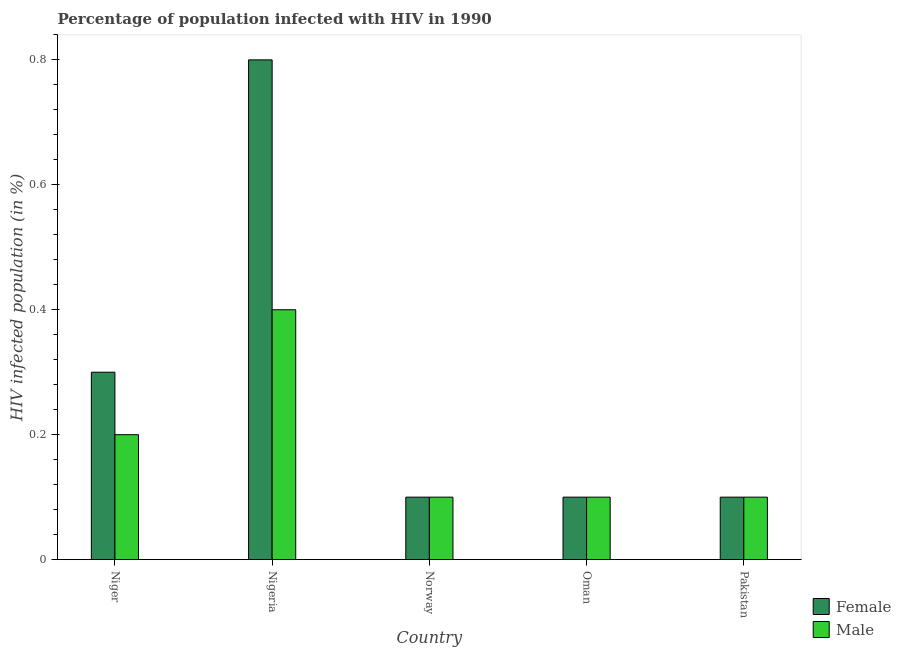What is the percentage of males who are infected with hiv in Oman?
Offer a terse response. 0.1. Across all countries, what is the maximum percentage of females who are infected with hiv?
Your answer should be compact. 0.8. In which country was the percentage of males who are infected with hiv maximum?
Offer a very short reply. Nigeria. What is the total percentage of females who are infected with hiv in the graph?
Ensure brevity in your answer.  1.4. What is the difference between the percentage of females who are infected with hiv in Nigeria and that in Norway?
Make the answer very short. 0.7. What is the average percentage of females who are infected with hiv per country?
Your answer should be very brief. 0.28. What is the ratio of the percentage of males who are infected with hiv in Niger to that in Nigeria?
Offer a very short reply. 0.5. What is the difference between the highest and the lowest percentage of females who are infected with hiv?
Make the answer very short. 0.7. Is the sum of the percentage of males who are infected with hiv in Norway and Oman greater than the maximum percentage of females who are infected with hiv across all countries?
Give a very brief answer. No. What does the 2nd bar from the left in Oman represents?
Offer a very short reply. Male. What does the 2nd bar from the right in Niger represents?
Ensure brevity in your answer.  Female. How many bars are there?
Make the answer very short. 10. Are all the bars in the graph horizontal?
Offer a terse response. No. Are the values on the major ticks of Y-axis written in scientific E-notation?
Your answer should be compact. No. Does the graph contain any zero values?
Your answer should be very brief. No. Does the graph contain grids?
Keep it short and to the point. No. How are the legend labels stacked?
Your answer should be very brief. Vertical. What is the title of the graph?
Your response must be concise. Percentage of population infected with HIV in 1990. Does "Research and Development" appear as one of the legend labels in the graph?
Offer a terse response. No. What is the label or title of the X-axis?
Your answer should be compact. Country. What is the label or title of the Y-axis?
Provide a short and direct response. HIV infected population (in %). What is the HIV infected population (in %) of Female in Norway?
Your answer should be compact. 0.1. What is the HIV infected population (in %) of Male in Oman?
Give a very brief answer. 0.1. What is the HIV infected population (in %) in Female in Pakistan?
Ensure brevity in your answer.  0.1. What is the HIV infected population (in %) in Male in Pakistan?
Provide a short and direct response. 0.1. Across all countries, what is the maximum HIV infected population (in %) in Male?
Provide a succinct answer. 0.4. Across all countries, what is the minimum HIV infected population (in %) in Female?
Give a very brief answer. 0.1. What is the difference between the HIV infected population (in %) of Female in Niger and that in Pakistan?
Your answer should be compact. 0.2. What is the difference between the HIV infected population (in %) in Male in Nigeria and that in Norway?
Make the answer very short. 0.3. What is the difference between the HIV infected population (in %) in Female in Nigeria and that in Oman?
Provide a short and direct response. 0.7. What is the difference between the HIV infected population (in %) in Male in Nigeria and that in Oman?
Ensure brevity in your answer.  0.3. What is the difference between the HIV infected population (in %) in Female in Nigeria and that in Pakistan?
Offer a terse response. 0.7. What is the difference between the HIV infected population (in %) of Male in Norway and that in Oman?
Make the answer very short. 0. What is the difference between the HIV infected population (in %) of Male in Norway and that in Pakistan?
Offer a terse response. 0. What is the difference between the HIV infected population (in %) of Male in Oman and that in Pakistan?
Ensure brevity in your answer.  0. What is the difference between the HIV infected population (in %) of Female in Niger and the HIV infected population (in %) of Male in Nigeria?
Provide a short and direct response. -0.1. What is the difference between the HIV infected population (in %) in Female in Niger and the HIV infected population (in %) in Male in Oman?
Provide a short and direct response. 0.2. What is the difference between the HIV infected population (in %) in Female in Niger and the HIV infected population (in %) in Male in Pakistan?
Your response must be concise. 0.2. What is the difference between the HIV infected population (in %) of Female in Nigeria and the HIV infected population (in %) of Male in Norway?
Your answer should be compact. 0.7. What is the difference between the HIV infected population (in %) of Female in Nigeria and the HIV infected population (in %) of Male in Pakistan?
Ensure brevity in your answer.  0.7. What is the difference between the HIV infected population (in %) in Female in Oman and the HIV infected population (in %) in Male in Pakistan?
Provide a succinct answer. 0. What is the average HIV infected population (in %) of Female per country?
Your answer should be compact. 0.28. What is the average HIV infected population (in %) of Male per country?
Ensure brevity in your answer.  0.18. What is the difference between the HIV infected population (in %) of Female and HIV infected population (in %) of Male in Nigeria?
Provide a succinct answer. 0.4. What is the difference between the HIV infected population (in %) in Female and HIV infected population (in %) in Male in Pakistan?
Offer a very short reply. 0. What is the ratio of the HIV infected population (in %) in Female in Niger to that in Norway?
Offer a very short reply. 3. What is the ratio of the HIV infected population (in %) in Female in Niger to that in Pakistan?
Keep it short and to the point. 3. What is the ratio of the HIV infected population (in %) of Female in Nigeria to that in Norway?
Your answer should be very brief. 8. What is the ratio of the HIV infected population (in %) in Male in Nigeria to that in Norway?
Provide a succinct answer. 4. What is the ratio of the HIV infected population (in %) of Female in Nigeria to that in Oman?
Offer a terse response. 8. What is the ratio of the HIV infected population (in %) of Male in Nigeria to that in Oman?
Keep it short and to the point. 4. What is the ratio of the HIV infected population (in %) of Male in Nigeria to that in Pakistan?
Make the answer very short. 4. What is the ratio of the HIV infected population (in %) in Female in Norway to that in Oman?
Your response must be concise. 1. What is the ratio of the HIV infected population (in %) in Male in Norway to that in Oman?
Provide a short and direct response. 1. What is the ratio of the HIV infected population (in %) of Female in Norway to that in Pakistan?
Your answer should be compact. 1. What is the ratio of the HIV infected population (in %) in Male in Norway to that in Pakistan?
Provide a succinct answer. 1. What is the ratio of the HIV infected population (in %) of Female in Oman to that in Pakistan?
Keep it short and to the point. 1. 